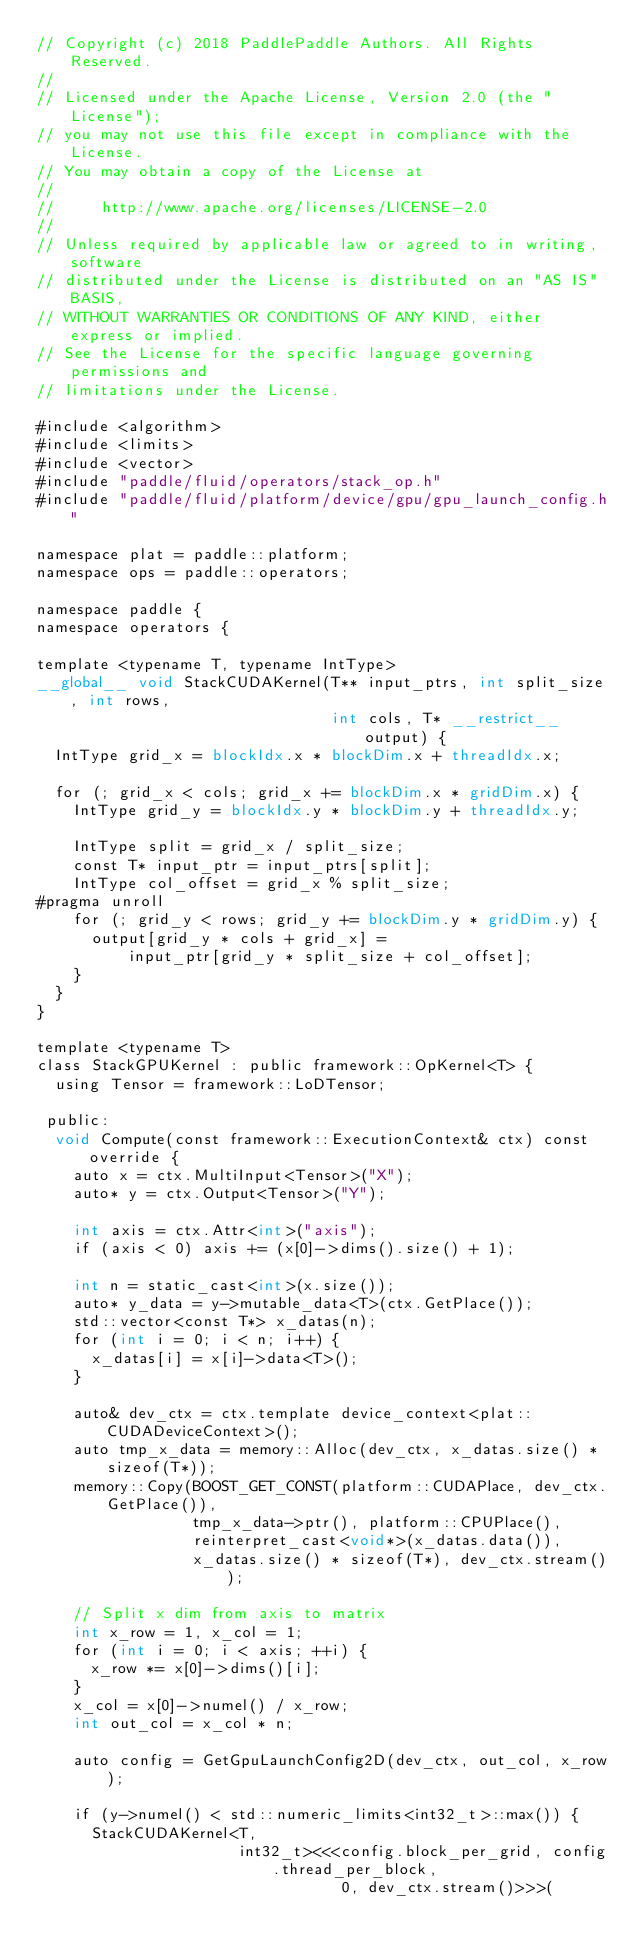<code> <loc_0><loc_0><loc_500><loc_500><_Cuda_>// Copyright (c) 2018 PaddlePaddle Authors. All Rights Reserved.
//
// Licensed under the Apache License, Version 2.0 (the "License");
// you may not use this file except in compliance with the License.
// You may obtain a copy of the License at
//
//     http://www.apache.org/licenses/LICENSE-2.0
//
// Unless required by applicable law or agreed to in writing, software
// distributed under the License is distributed on an "AS IS" BASIS,
// WITHOUT WARRANTIES OR CONDITIONS OF ANY KIND, either express or implied.
// See the License for the specific language governing permissions and
// limitations under the License.

#include <algorithm>
#include <limits>
#include <vector>
#include "paddle/fluid/operators/stack_op.h"
#include "paddle/fluid/platform/device/gpu/gpu_launch_config.h"

namespace plat = paddle::platform;
namespace ops = paddle::operators;

namespace paddle {
namespace operators {

template <typename T, typename IntType>
__global__ void StackCUDAKernel(T** input_ptrs, int split_size, int rows,
                                int cols, T* __restrict__ output) {
  IntType grid_x = blockIdx.x * blockDim.x + threadIdx.x;

  for (; grid_x < cols; grid_x += blockDim.x * gridDim.x) {
    IntType grid_y = blockIdx.y * blockDim.y + threadIdx.y;

    IntType split = grid_x / split_size;
    const T* input_ptr = input_ptrs[split];
    IntType col_offset = grid_x % split_size;
#pragma unroll
    for (; grid_y < rows; grid_y += blockDim.y * gridDim.y) {
      output[grid_y * cols + grid_x] =
          input_ptr[grid_y * split_size + col_offset];
    }
  }
}

template <typename T>
class StackGPUKernel : public framework::OpKernel<T> {
  using Tensor = framework::LoDTensor;

 public:
  void Compute(const framework::ExecutionContext& ctx) const override {
    auto x = ctx.MultiInput<Tensor>("X");
    auto* y = ctx.Output<Tensor>("Y");

    int axis = ctx.Attr<int>("axis");
    if (axis < 0) axis += (x[0]->dims().size() + 1);

    int n = static_cast<int>(x.size());
    auto* y_data = y->mutable_data<T>(ctx.GetPlace());
    std::vector<const T*> x_datas(n);
    for (int i = 0; i < n; i++) {
      x_datas[i] = x[i]->data<T>();
    }

    auto& dev_ctx = ctx.template device_context<plat::CUDADeviceContext>();
    auto tmp_x_data = memory::Alloc(dev_ctx, x_datas.size() * sizeof(T*));
    memory::Copy(BOOST_GET_CONST(platform::CUDAPlace, dev_ctx.GetPlace()),
                 tmp_x_data->ptr(), platform::CPUPlace(),
                 reinterpret_cast<void*>(x_datas.data()),
                 x_datas.size() * sizeof(T*), dev_ctx.stream());

    // Split x dim from axis to matrix
    int x_row = 1, x_col = 1;
    for (int i = 0; i < axis; ++i) {
      x_row *= x[0]->dims()[i];
    }
    x_col = x[0]->numel() / x_row;
    int out_col = x_col * n;

    auto config = GetGpuLaunchConfig2D(dev_ctx, out_col, x_row);

    if (y->numel() < std::numeric_limits<int32_t>::max()) {
      StackCUDAKernel<T,
                      int32_t><<<config.block_per_grid, config.thread_per_block,
                                 0, dev_ctx.stream()>>>(</code> 